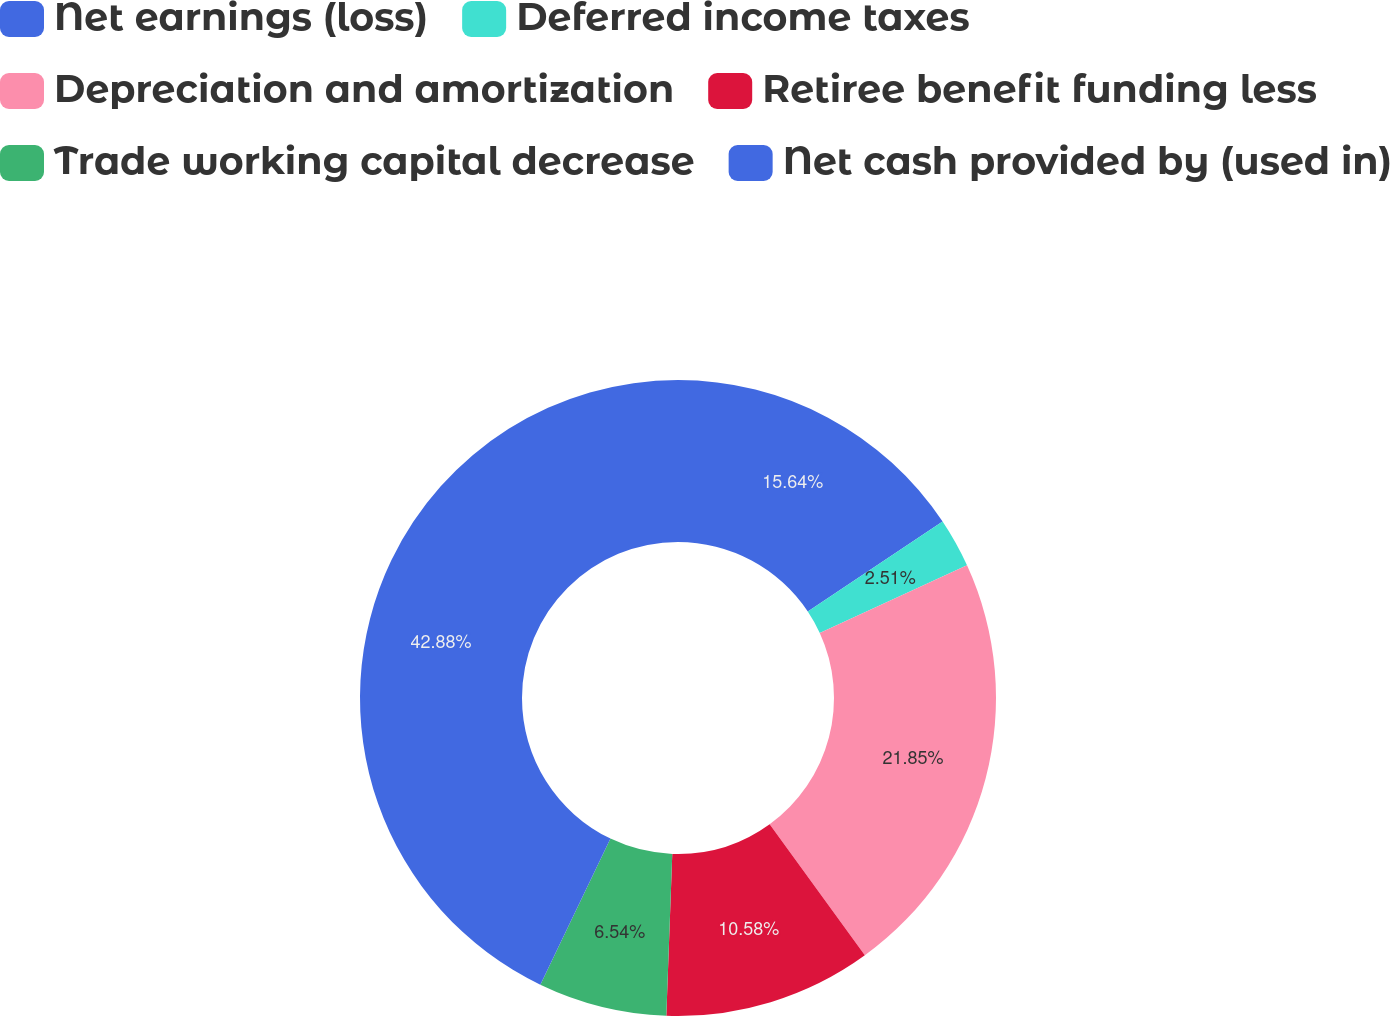<chart> <loc_0><loc_0><loc_500><loc_500><pie_chart><fcel>Net earnings (loss)<fcel>Deferred income taxes<fcel>Depreciation and amortization<fcel>Retiree benefit funding less<fcel>Trade working capital decrease<fcel>Net cash provided by (used in)<nl><fcel>15.64%<fcel>2.51%<fcel>21.85%<fcel>10.58%<fcel>6.54%<fcel>42.87%<nl></chart> 